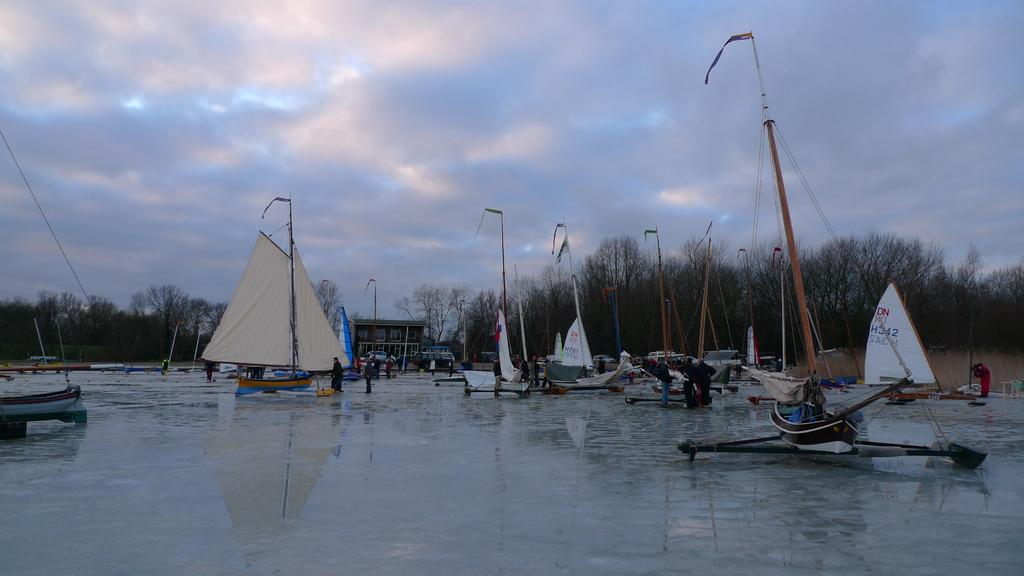What is the primary element in the image? There is water in the image. What types of boats are present in the image? The boats in the image have colors including yellow, blue, white, and black. What are the people in the image doing? There are people standing in the image. What can be seen in the background of the image? There are trees, a building, and the sky visible in the background of the image. What type of guitar can be seen in the image? There is no guitar present in the image. How many spoons are visible in the image? There are no spoons visible in the image. 